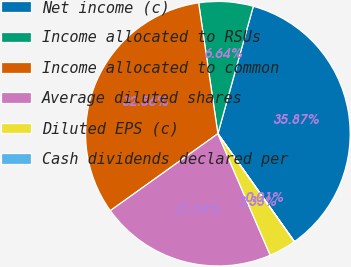<chart> <loc_0><loc_0><loc_500><loc_500><pie_chart><fcel>Net income (c)<fcel>Income allocated to RSUs<fcel>Income allocated to common<fcel>Average diluted shares<fcel>Diluted EPS (c)<fcel>Cash dividends declared per<nl><fcel>35.87%<fcel>6.64%<fcel>32.56%<fcel>21.59%<fcel>3.33%<fcel>0.01%<nl></chart> 